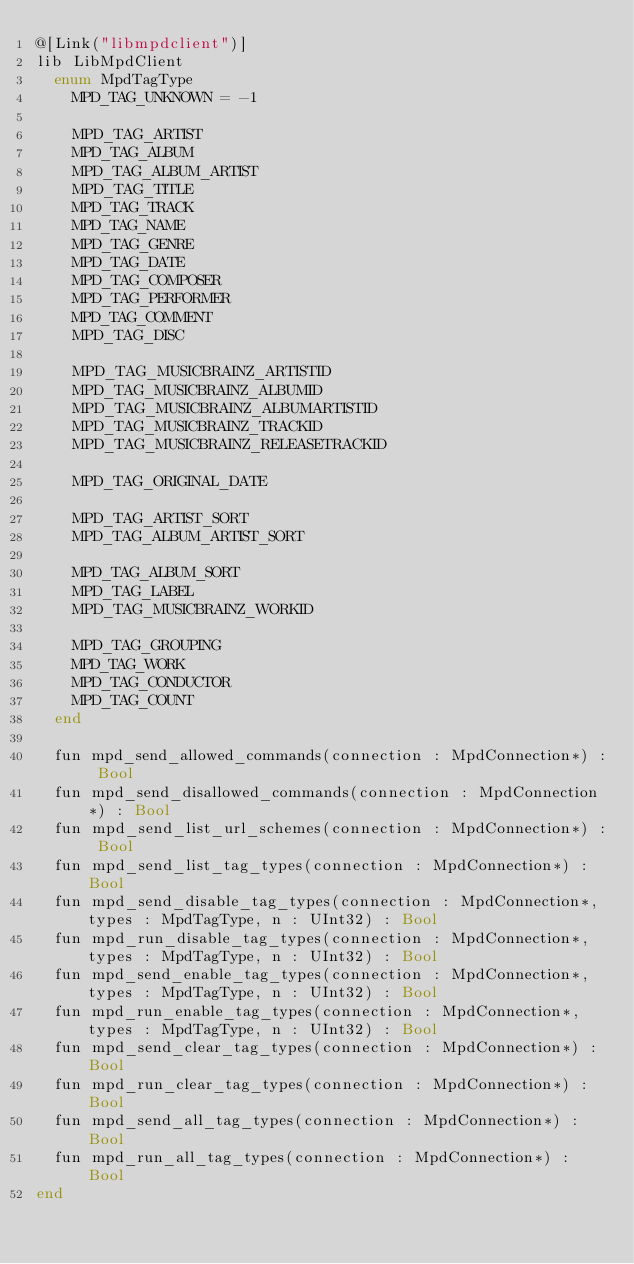<code> <loc_0><loc_0><loc_500><loc_500><_Crystal_>@[Link("libmpdclient")]
lib LibMpdClient
  enum MpdTagType
    MPD_TAG_UNKNOWN = -1

    MPD_TAG_ARTIST
    MPD_TAG_ALBUM
    MPD_TAG_ALBUM_ARTIST
    MPD_TAG_TITLE
    MPD_TAG_TRACK
    MPD_TAG_NAME
    MPD_TAG_GENRE
    MPD_TAG_DATE
    MPD_TAG_COMPOSER
    MPD_TAG_PERFORMER
    MPD_TAG_COMMENT
    MPD_TAG_DISC

    MPD_TAG_MUSICBRAINZ_ARTISTID
    MPD_TAG_MUSICBRAINZ_ALBUMID
    MPD_TAG_MUSICBRAINZ_ALBUMARTISTID
    MPD_TAG_MUSICBRAINZ_TRACKID
    MPD_TAG_MUSICBRAINZ_RELEASETRACKID

    MPD_TAG_ORIGINAL_DATE

    MPD_TAG_ARTIST_SORT
    MPD_TAG_ALBUM_ARTIST_SORT

    MPD_TAG_ALBUM_SORT
    MPD_TAG_LABEL
    MPD_TAG_MUSICBRAINZ_WORKID

    MPD_TAG_GROUPING
    MPD_TAG_WORK
    MPD_TAG_CONDUCTOR
    MPD_TAG_COUNT
  end

  fun mpd_send_allowed_commands(connection : MpdConnection*) : Bool
  fun mpd_send_disallowed_commands(connection : MpdConnection*) : Bool
  fun mpd_send_list_url_schemes(connection : MpdConnection*) : Bool
  fun mpd_send_list_tag_types(connection : MpdConnection*) : Bool
  fun mpd_send_disable_tag_types(connection : MpdConnection*, types : MpdTagType, n : UInt32) : Bool
  fun mpd_run_disable_tag_types(connection : MpdConnection*, types : MpdTagType, n : UInt32) : Bool
  fun mpd_send_enable_tag_types(connection : MpdConnection*, types : MpdTagType, n : UInt32) : Bool
  fun mpd_run_enable_tag_types(connection : MpdConnection*, types : MpdTagType, n : UInt32) : Bool
  fun mpd_send_clear_tag_types(connection : MpdConnection*) : Bool
  fun mpd_run_clear_tag_types(connection : MpdConnection*) : Bool
  fun mpd_send_all_tag_types(connection : MpdConnection*) : Bool
  fun mpd_run_all_tag_types(connection : MpdConnection*) : Bool
end
</code> 